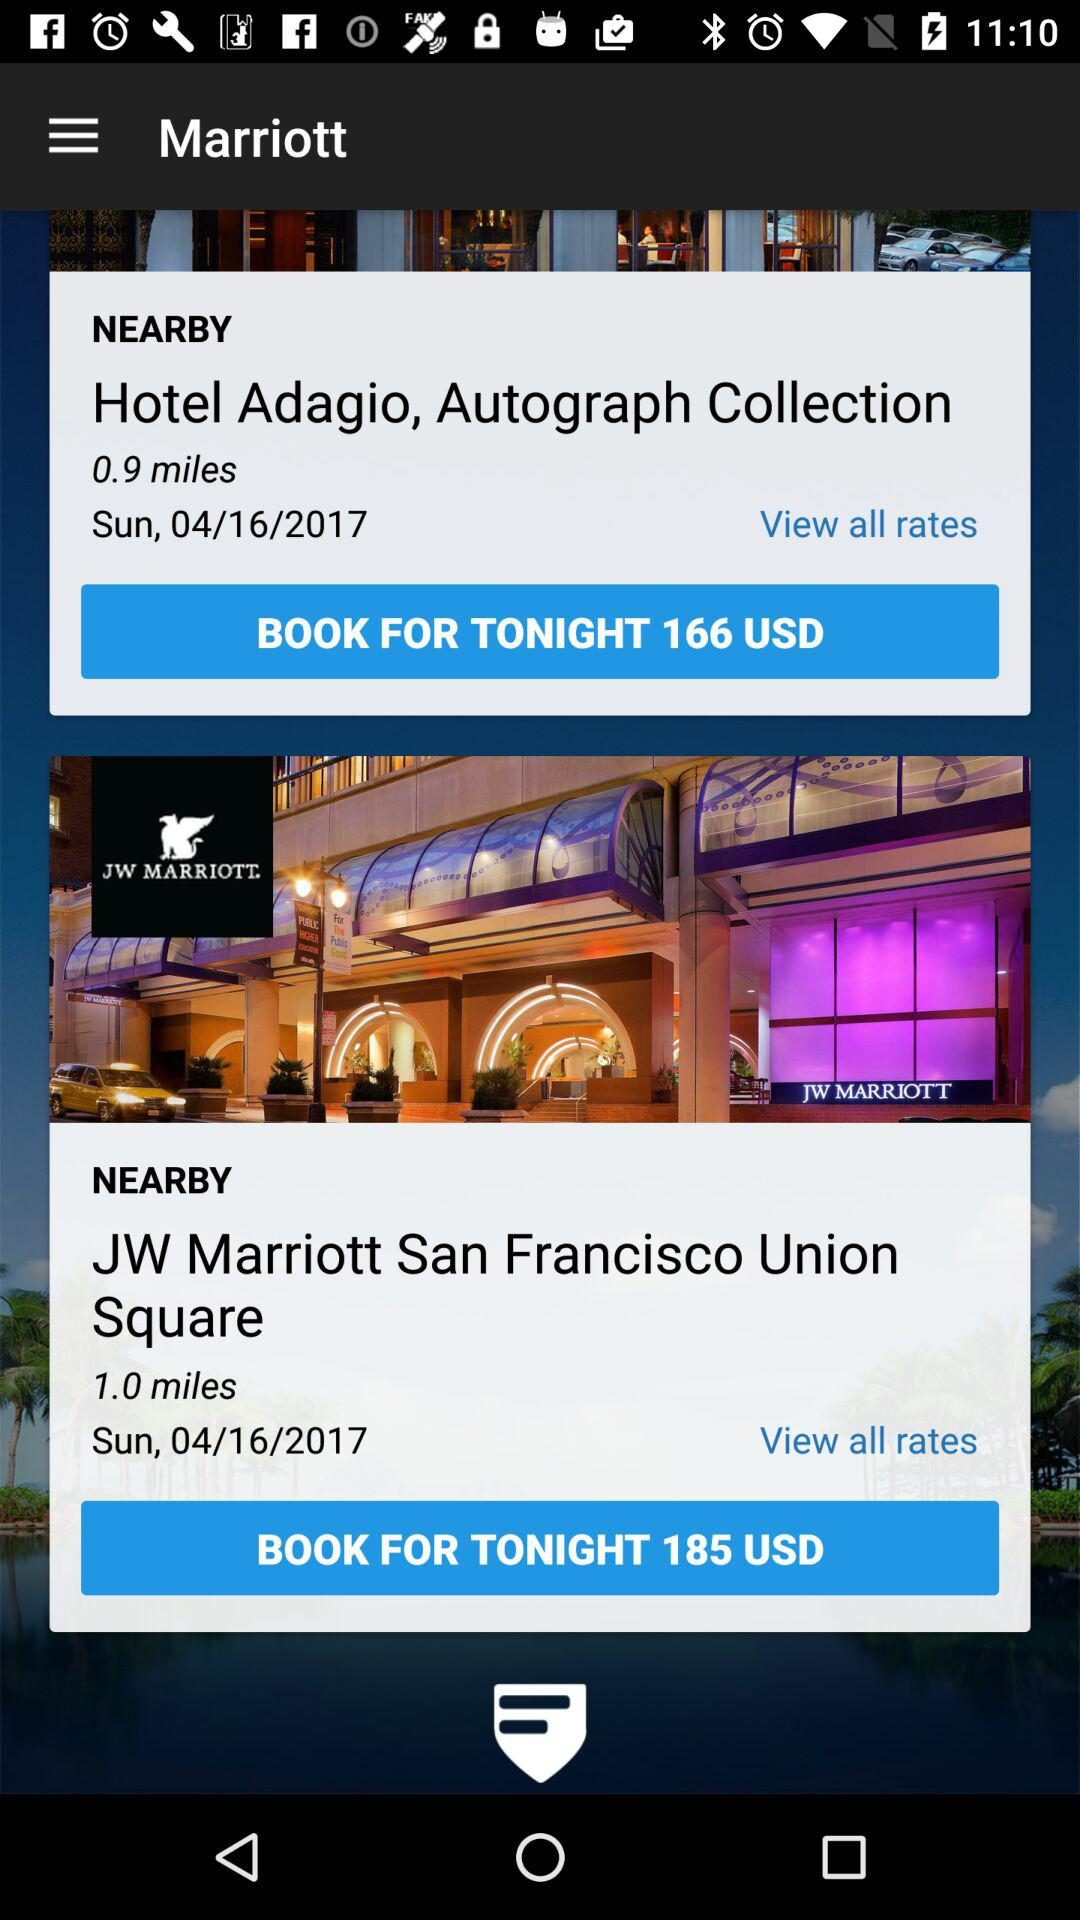What is the booking price of a room at the "Hotel Adagio"? The booking price of a room at the "Hotel Adagio" is 166 USD. 